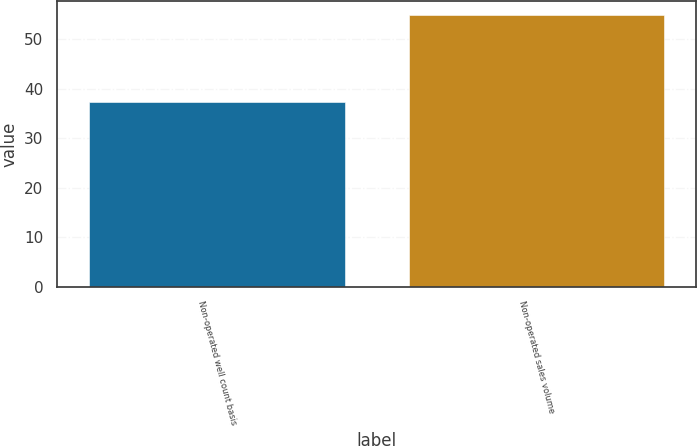<chart> <loc_0><loc_0><loc_500><loc_500><bar_chart><fcel>Non-operated well count basis<fcel>Non-operated sales volume<nl><fcel>37.2<fcel>54.9<nl></chart> 